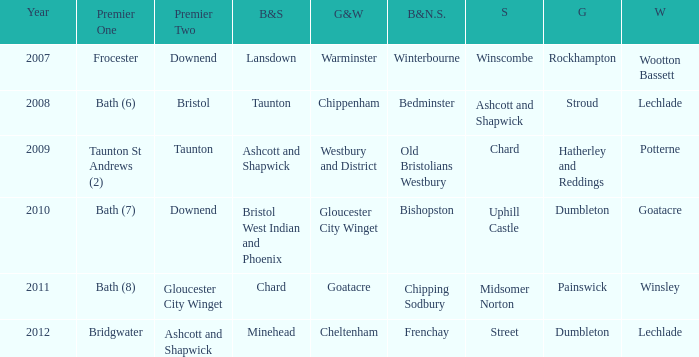What is the somerset for the  year 2009? Chard. 